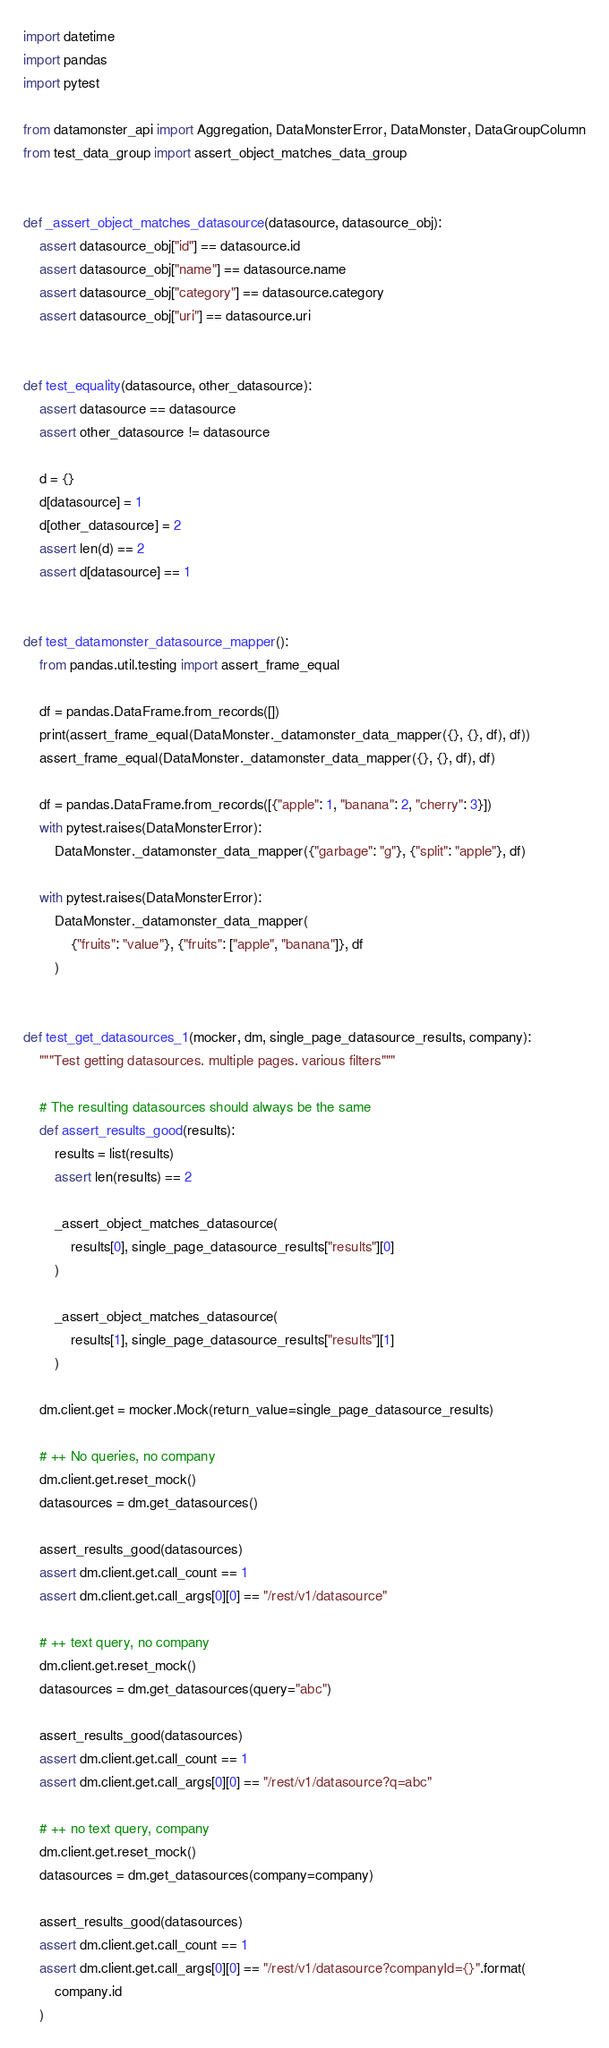<code> <loc_0><loc_0><loc_500><loc_500><_Python_>import datetime
import pandas
import pytest

from datamonster_api import Aggregation, DataMonsterError, DataMonster, DataGroupColumn
from test_data_group import assert_object_matches_data_group


def _assert_object_matches_datasource(datasource, datasource_obj):
    assert datasource_obj["id"] == datasource.id
    assert datasource_obj["name"] == datasource.name
    assert datasource_obj["category"] == datasource.category
    assert datasource_obj["uri"] == datasource.uri


def test_equality(datasource, other_datasource):
    assert datasource == datasource
    assert other_datasource != datasource

    d = {}
    d[datasource] = 1
    d[other_datasource] = 2
    assert len(d) == 2
    assert d[datasource] == 1


def test_datamonster_datasource_mapper():
    from pandas.util.testing import assert_frame_equal

    df = pandas.DataFrame.from_records([])
    print(assert_frame_equal(DataMonster._datamonster_data_mapper({}, {}, df), df))
    assert_frame_equal(DataMonster._datamonster_data_mapper({}, {}, df), df)

    df = pandas.DataFrame.from_records([{"apple": 1, "banana": 2, "cherry": 3}])
    with pytest.raises(DataMonsterError):
        DataMonster._datamonster_data_mapper({"garbage": "g"}, {"split": "apple"}, df)

    with pytest.raises(DataMonsterError):
        DataMonster._datamonster_data_mapper(
            {"fruits": "value"}, {"fruits": ["apple", "banana"]}, df
        )


def test_get_datasources_1(mocker, dm, single_page_datasource_results, company):
    """Test getting datasources. multiple pages. various filters"""

    # The resulting datasources should always be the same
    def assert_results_good(results):
        results = list(results)
        assert len(results) == 2

        _assert_object_matches_datasource(
            results[0], single_page_datasource_results["results"][0]
        )

        _assert_object_matches_datasource(
            results[1], single_page_datasource_results["results"][1]
        )

    dm.client.get = mocker.Mock(return_value=single_page_datasource_results)

    # ++ No queries, no company
    dm.client.get.reset_mock()
    datasources = dm.get_datasources()

    assert_results_good(datasources)
    assert dm.client.get.call_count == 1
    assert dm.client.get.call_args[0][0] == "/rest/v1/datasource"

    # ++ text query, no company
    dm.client.get.reset_mock()
    datasources = dm.get_datasources(query="abc")

    assert_results_good(datasources)
    assert dm.client.get.call_count == 1
    assert dm.client.get.call_args[0][0] == "/rest/v1/datasource?q=abc"

    # ++ no text query, company
    dm.client.get.reset_mock()
    datasources = dm.get_datasources(company=company)

    assert_results_good(datasources)
    assert dm.client.get.call_count == 1
    assert dm.client.get.call_args[0][0] == "/rest/v1/datasource?companyId={}".format(
        company.id
    )
</code> 